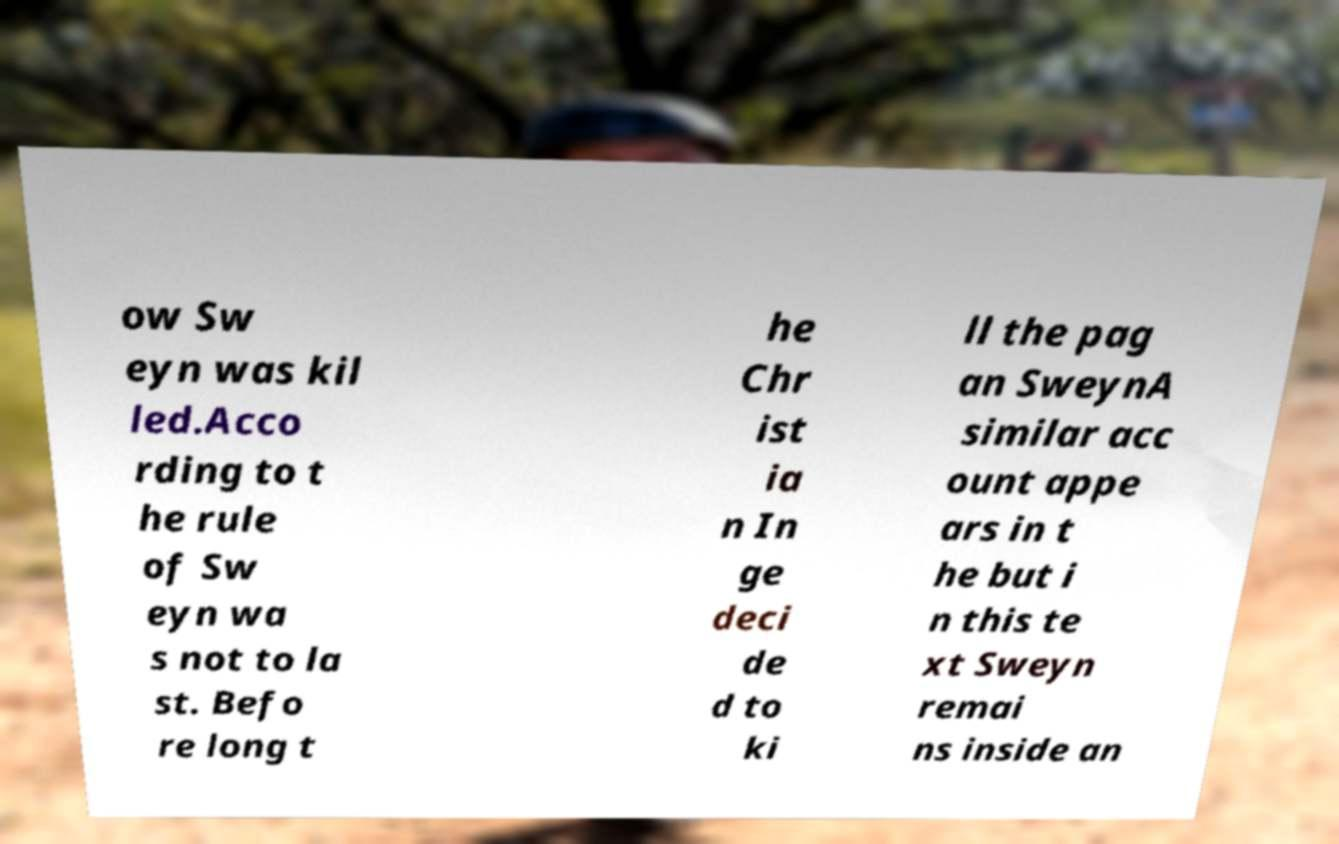There's text embedded in this image that I need extracted. Can you transcribe it verbatim? ow Sw eyn was kil led.Acco rding to t he rule of Sw eyn wa s not to la st. Befo re long t he Chr ist ia n In ge deci de d to ki ll the pag an SweynA similar acc ount appe ars in t he but i n this te xt Sweyn remai ns inside an 